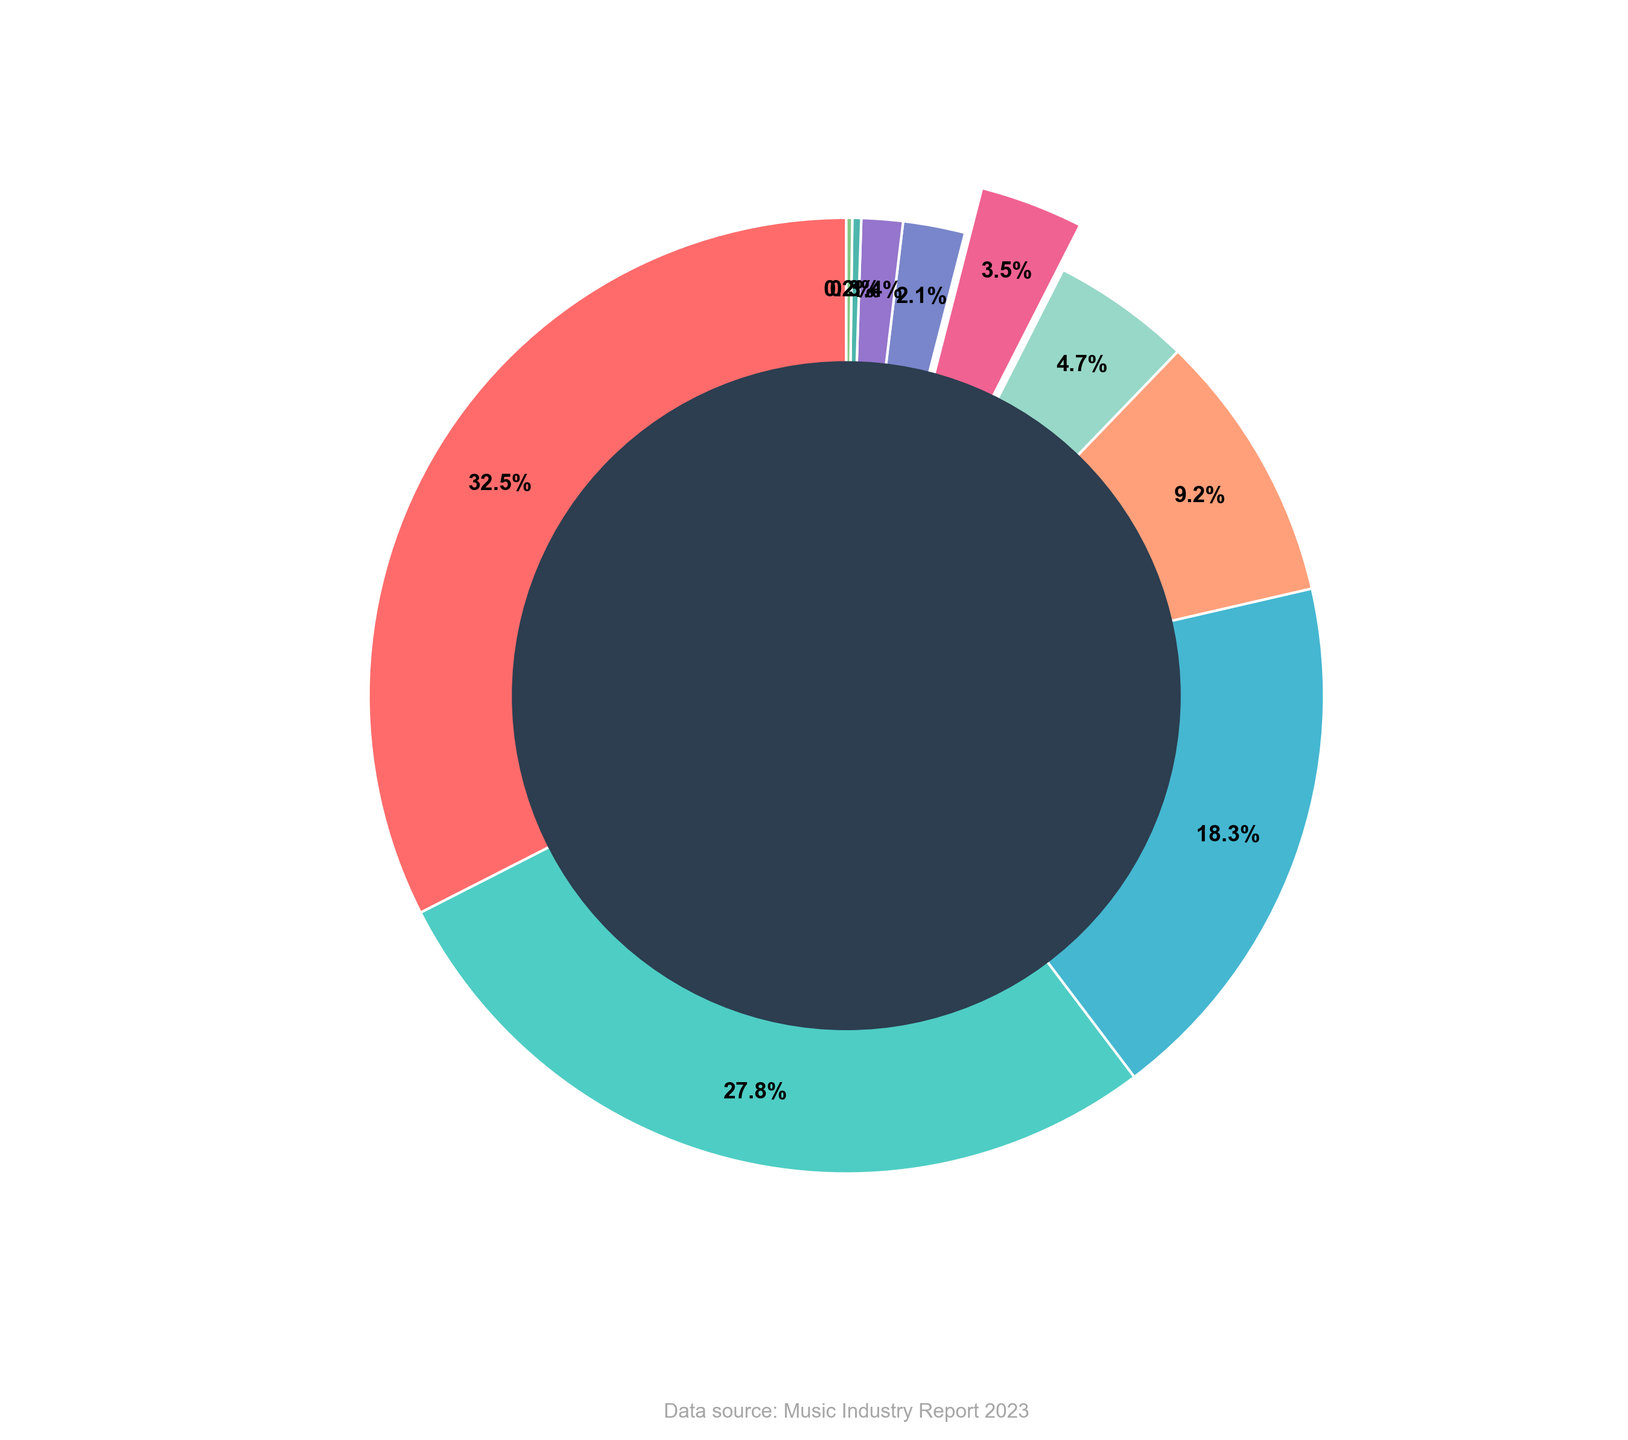Which record label has the highest market share? Look for the slice with the largest percentage in the pie chart. Universal Music Group Belgium has the highest market share at 32.5%.
Answer: Universal Music Group Belgium What is the combined market share of Sony Music Entertainment Belgium and Warner Music Belgium? Identify the market shares for Sony Music Entertainment Belgium (27.8%) and Warner Music Belgium (18.3%). Add these two percentages: 27.8 + 18.3 = 46.1%.
Answer: 46.1% Which record label's slice is highlighted (exploded) in the pie chart? Look for the slice that appears to be pulled out from the rest of the pie. Axelle Red's Independent Label (AXL Music) is the one that's highlighted.
Answer: Axelle Red's Independent Label (AXL Music) How does the market share of Axelle Red's Independent Label compare to CNR Records? Identify the market shares for Axelle Red's Independent Label (3.5%) and CNR Records (4.7%). Axelle Red's Independent Label has a smaller market share than CNR Records.
Answer: Smaller Which label has the least market share, and what is its percentage? Look for the smallest slice in the pie chart. Other Independent Labels has the least market share at 0.2%.
Answer: Other Independent Labels, 0.2% What percentage of the market share is controlled by labels that hold less than 5% individually? Identify the labels with market shares less than 5%: PIAS Belgium (9.2%), CNR Records (4.7%), Axelle Red's Independent Label (3.5%), N.E.W.S. Records (2.1%), Strictly Confidential (1.4%), Mostiko (0.3%), Other Independent Labels (0.2%). Add these: 4.7 + 3.5 + 2.1 + 1.4 + 0.3 + 0.2 = 12.2%.
Answer: 12.2% What is the difference in market share between the largest and smallest record labels? Find the market share of the largest (Universal Music Group Belgium at 32.5%) and the smallest (Other Independent Labels at 0.2%). Subtract the smallest from the largest: 32.5 - 0.2 = 32.3%.
Answer: 32.3% 